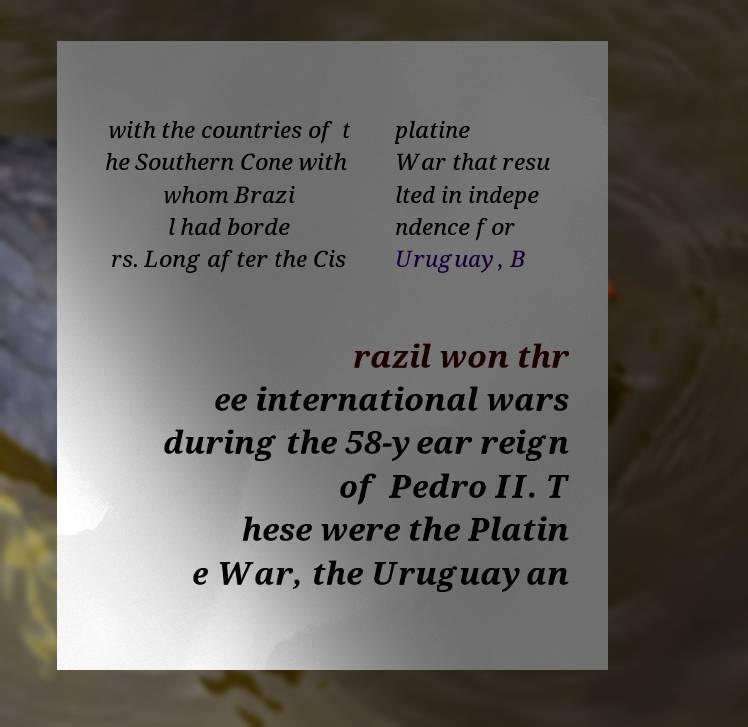Can you read and provide the text displayed in the image?This photo seems to have some interesting text. Can you extract and type it out for me? with the countries of t he Southern Cone with whom Brazi l had borde rs. Long after the Cis platine War that resu lted in indepe ndence for Uruguay, B razil won thr ee international wars during the 58-year reign of Pedro II. T hese were the Platin e War, the Uruguayan 